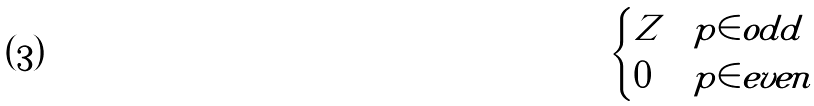<formula> <loc_0><loc_0><loc_500><loc_500>\begin{cases} Z & p \in o d d \\ 0 & p \in e v e n \end{cases}</formula> 